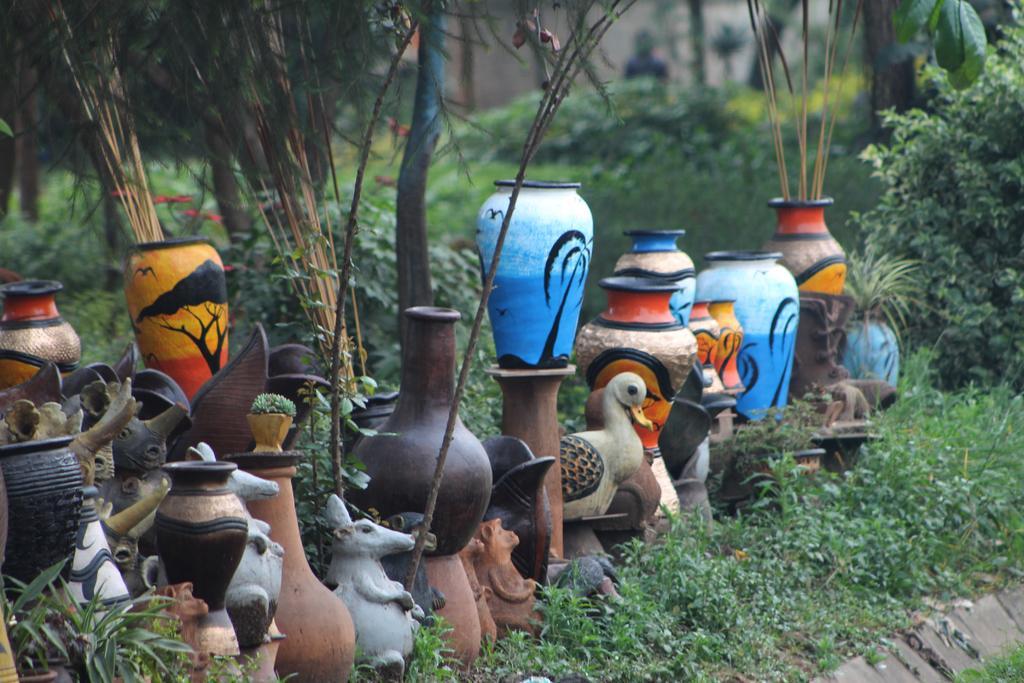Can you describe this image briefly? There are clay pots, flower vases and different animal toys in this image. At the back side there are trees. 